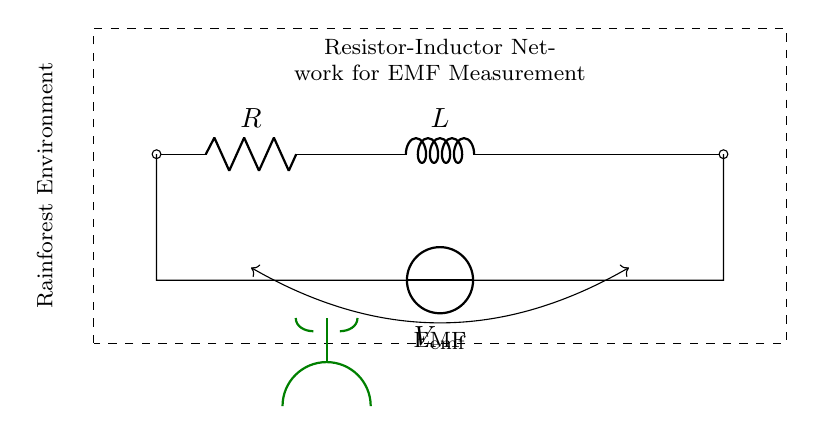What is the symbol used for the resistor? The symbol used for the resistor in the circuit is a zigzag line, which represents resistance in electrical diagrams.
Answer: Zigzag line What is the value of the inductor represented in the diagram? The inductor is represented by the letter "L" in the circuit diagram, which indicates the presence of inductance, but no specific numerical value is given.
Answer: L What does the dashed rectangle represent in this circuit? The dashed rectangle encloses the entire Resistor-Inductor network, indicating it is a single entity composed of various components designed for electromagnetic field measurements.
Answer: Resistor-Inductor network What is the purpose of the voltage source in this circuit? The voltage source labeled as "V emf" provides the necessary electrical potential to drive current through the resistor-inductor network, enabling the measurement of electromagnetic fields.
Answer: Drive current How do the resistor and inductor connect in this circuit? The resistor and inductor are connected in series, meaning the current flows through the resistor and then through the inductor sequentially, which affects their combined impedance.
Answer: In series What might the green lines indicate in the diagram? The green lines likely represent the signal paths or connections to sensors intended for measuring electromagnetic fields, relevant to the study of plants in rainforest environments.
Answer: Signal connections What impacts would an increased resistance have on this circuit? An increase in resistance would reduce the overall current flowing through the circuit according to Ohm's law, which could alter the effectiveness of the electromagnetic field measurement.
Answer: Decrease current 